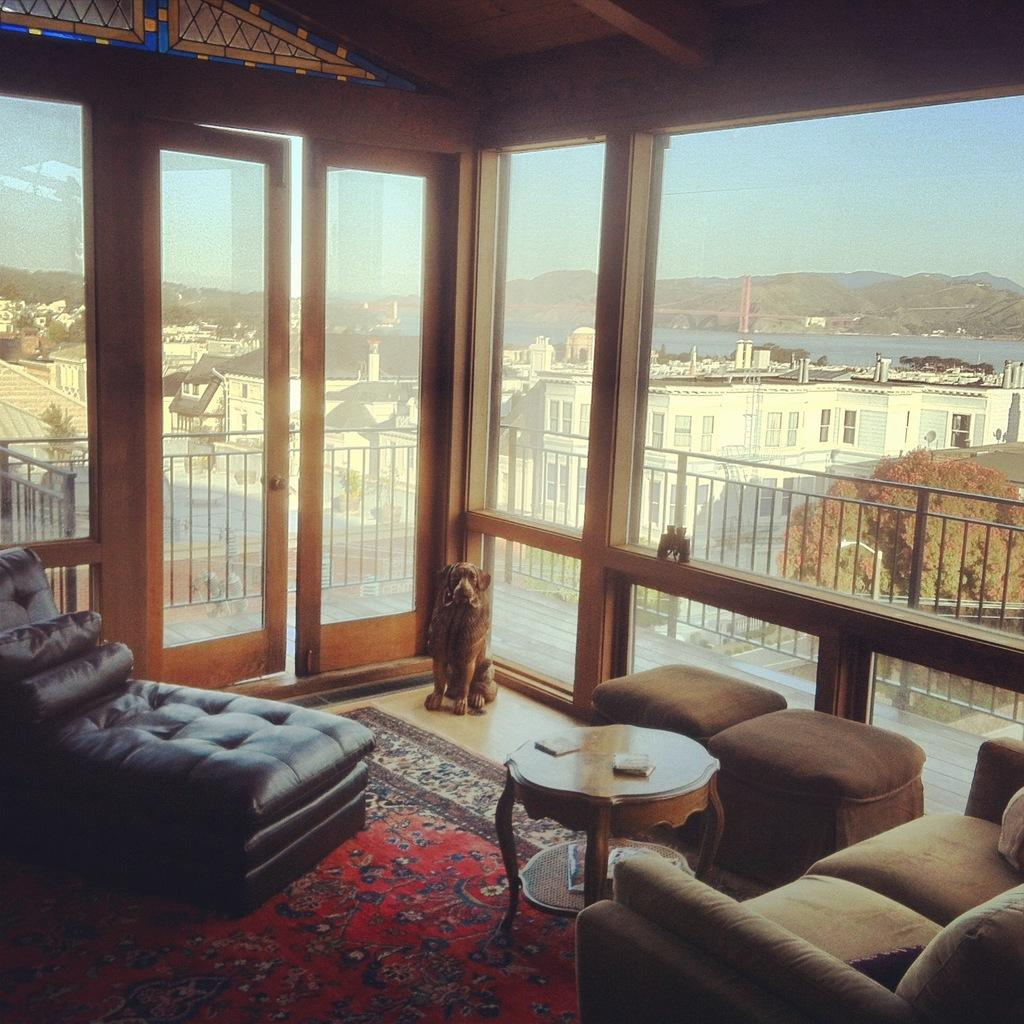What type of animal can be seen in the room? There is a dog in the room. What furniture is present in the room? There are chairs and a sofa in the room. What can be seen in the background of the room? There are buildings visible in the background. How many pizzas are on the sofa in the image? There are no pizzas present in the image; the sofa is empty. What type of ship can be seen sailing in the background? There is no ship visible in the background; only buildings are present. 